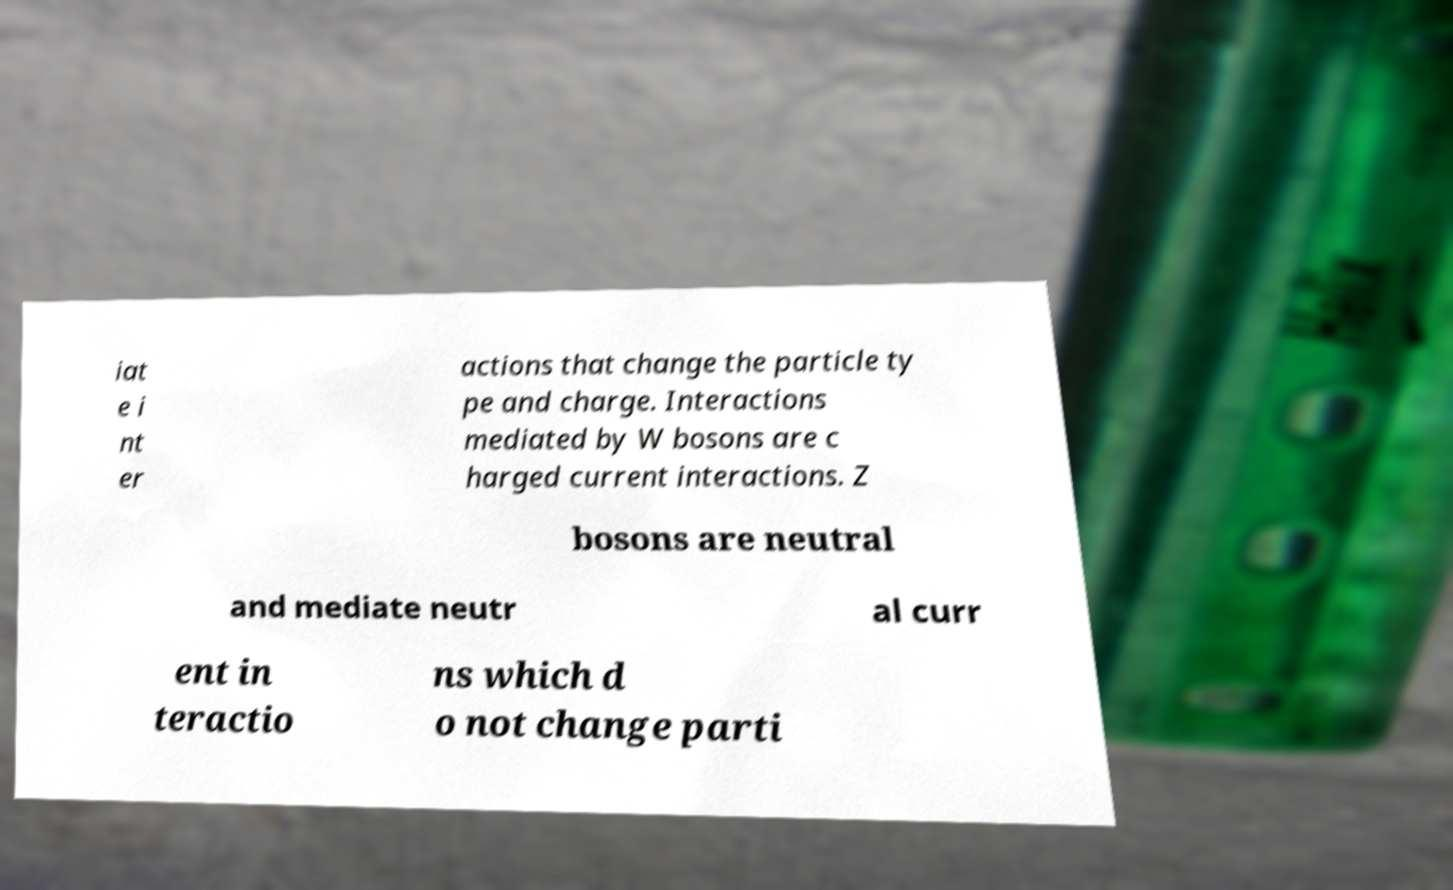There's text embedded in this image that I need extracted. Can you transcribe it verbatim? iat e i nt er actions that change the particle ty pe and charge. Interactions mediated by W bosons are c harged current interactions. Z bosons are neutral and mediate neutr al curr ent in teractio ns which d o not change parti 